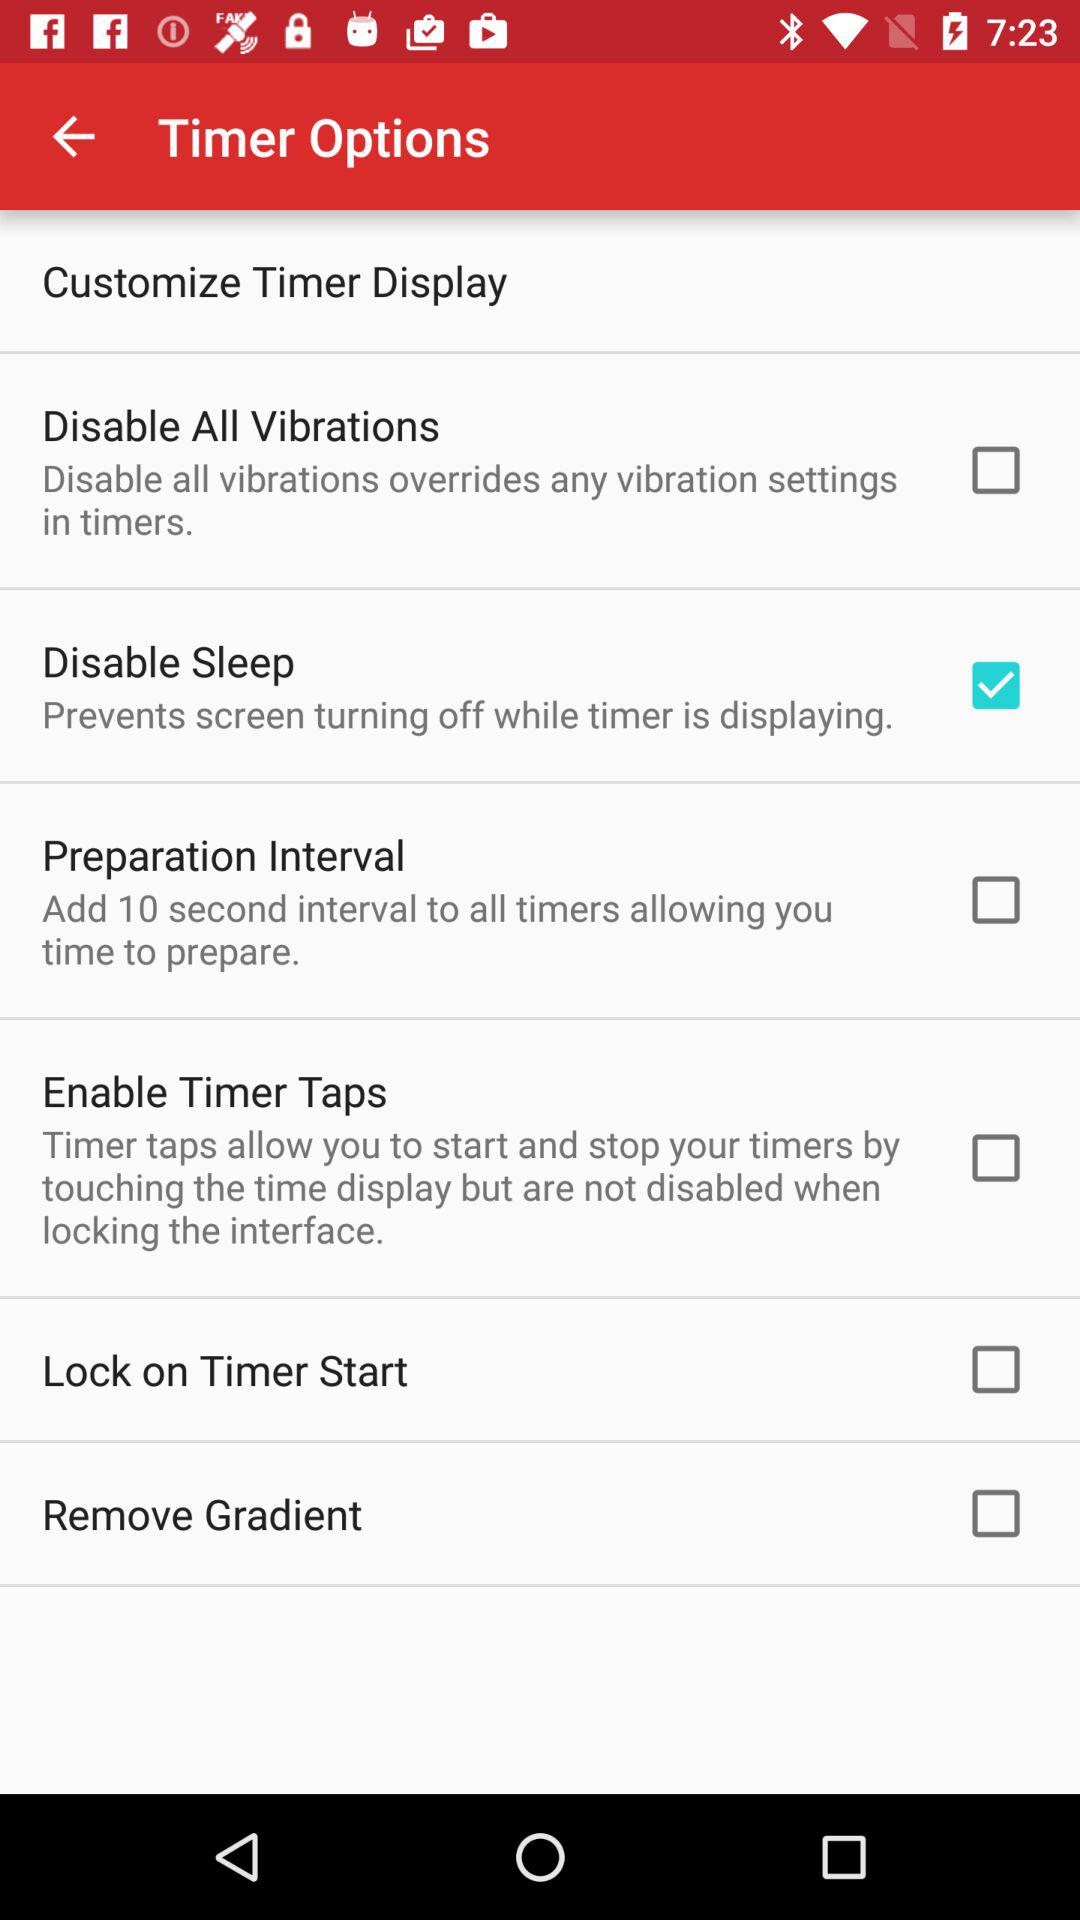What's the status of "Disable Sleep"? The status is "on". 